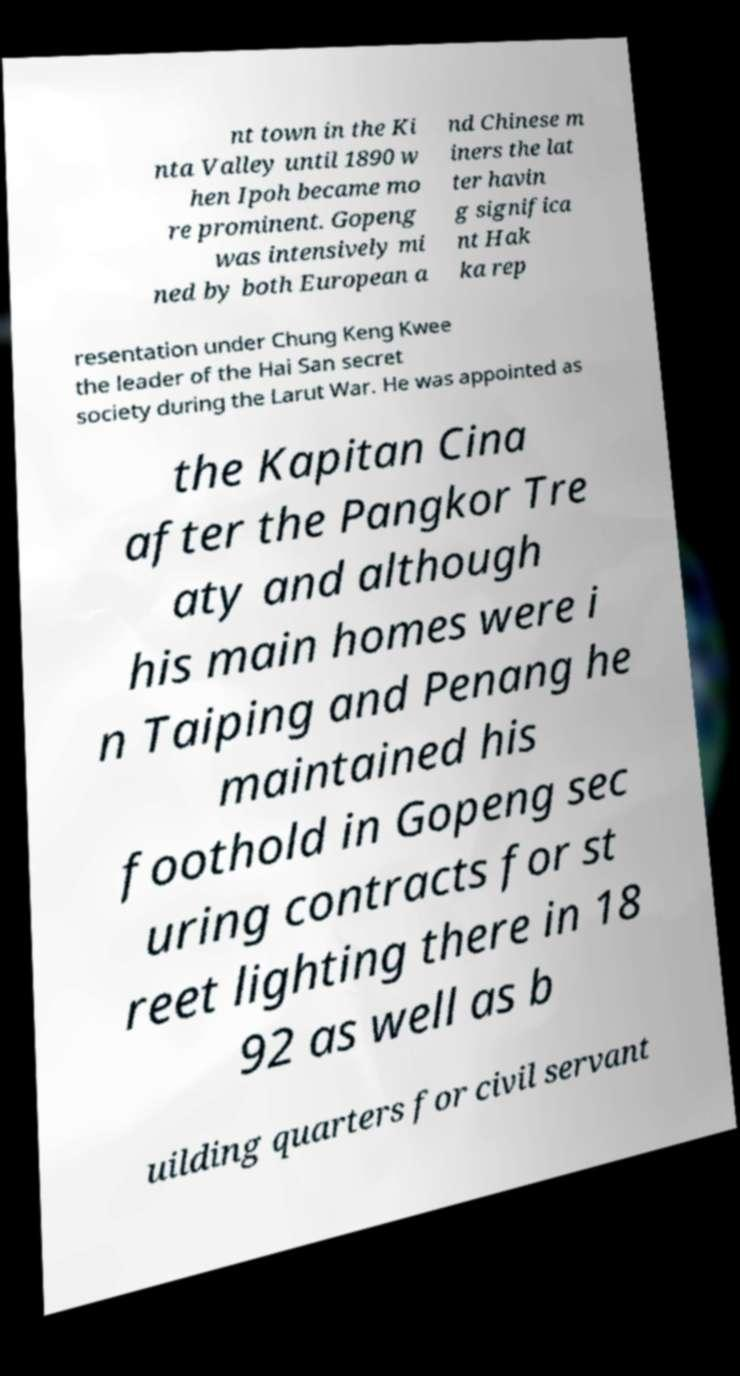Could you assist in decoding the text presented in this image and type it out clearly? nt town in the Ki nta Valley until 1890 w hen Ipoh became mo re prominent. Gopeng was intensively mi ned by both European a nd Chinese m iners the lat ter havin g significa nt Hak ka rep resentation under Chung Keng Kwee the leader of the Hai San secret society during the Larut War. He was appointed as the Kapitan Cina after the Pangkor Tre aty and although his main homes were i n Taiping and Penang he maintained his foothold in Gopeng sec uring contracts for st reet lighting there in 18 92 as well as b uilding quarters for civil servant 